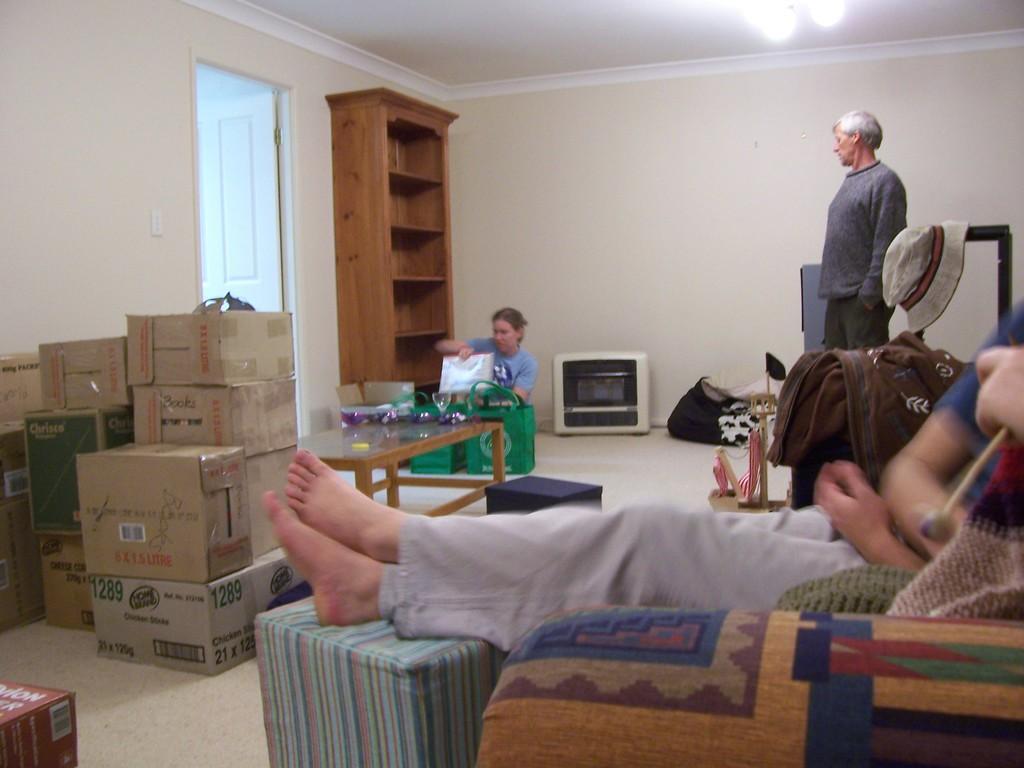How would you summarize this image in a sentence or two? In this image, There is a chair which is in yellow color and there is a person sitting on the chair, In the left side there are some brown color paper boxes and there is a table which is in brown color there are some objects kept on the table, In the background there is a white color and there is a person standing. 